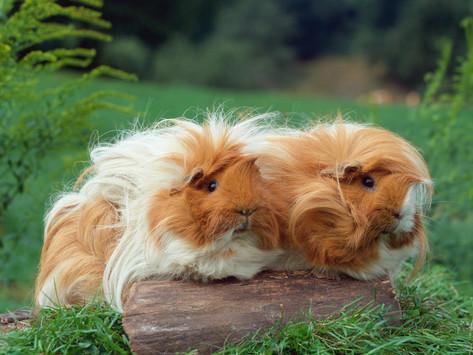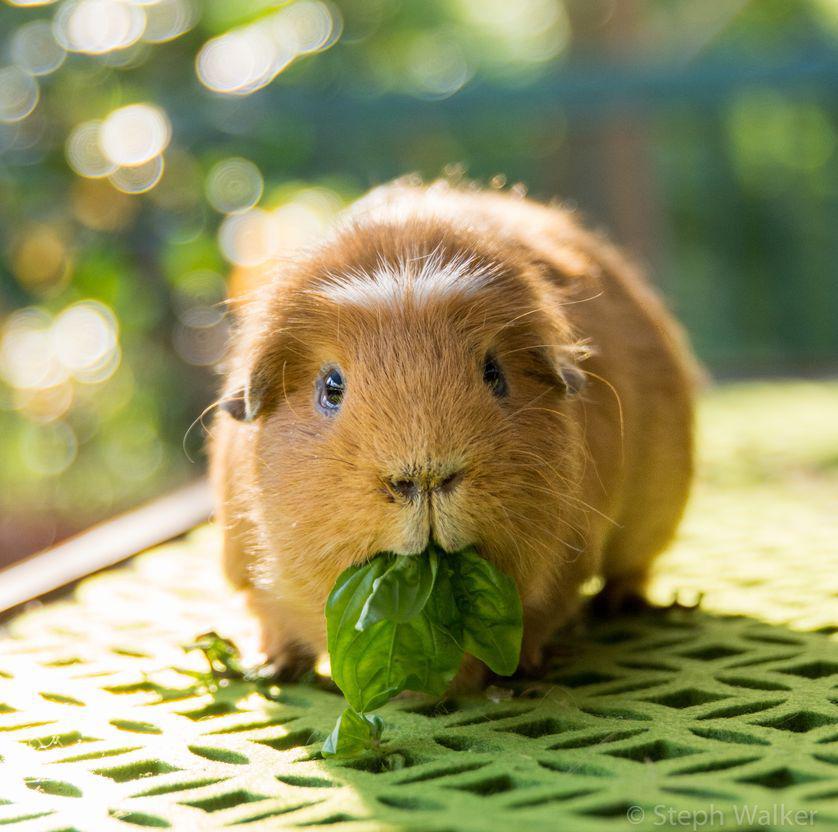The first image is the image on the left, the second image is the image on the right. Given the left and right images, does the statement "There are at most two guinea pigs." hold true? Answer yes or no. No. The first image is the image on the left, the second image is the image on the right. Evaluate the accuracy of this statement regarding the images: "There are two guinea pigs in the left image.". Is it true? Answer yes or no. Yes. 